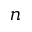Convert formula to latex. <formula><loc_0><loc_0><loc_500><loc_500>n</formula> 